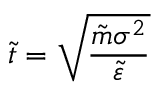<formula> <loc_0><loc_0><loc_500><loc_500>\tilde { t } = \sqrt { \frac { \tilde { m } \sigma ^ { 2 } } { \tilde { \varepsilon } } }</formula> 